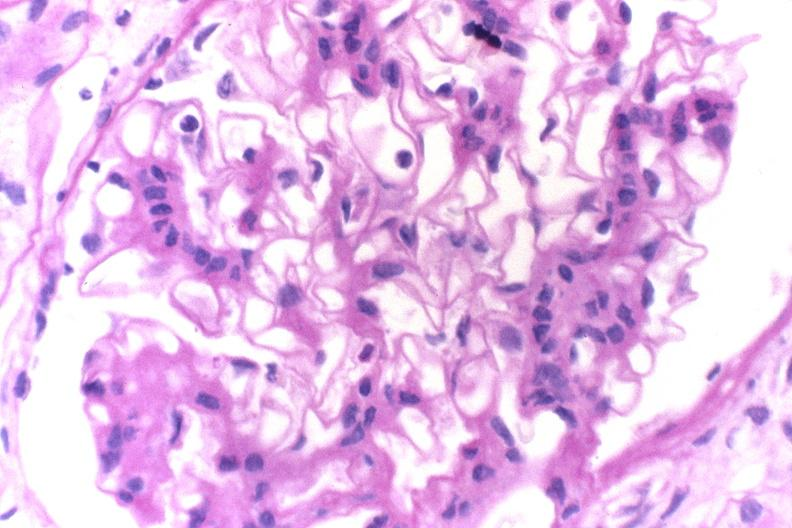does this image show glomerulonephritis, sle ii?
Answer the question using a single word or phrase. Yes 